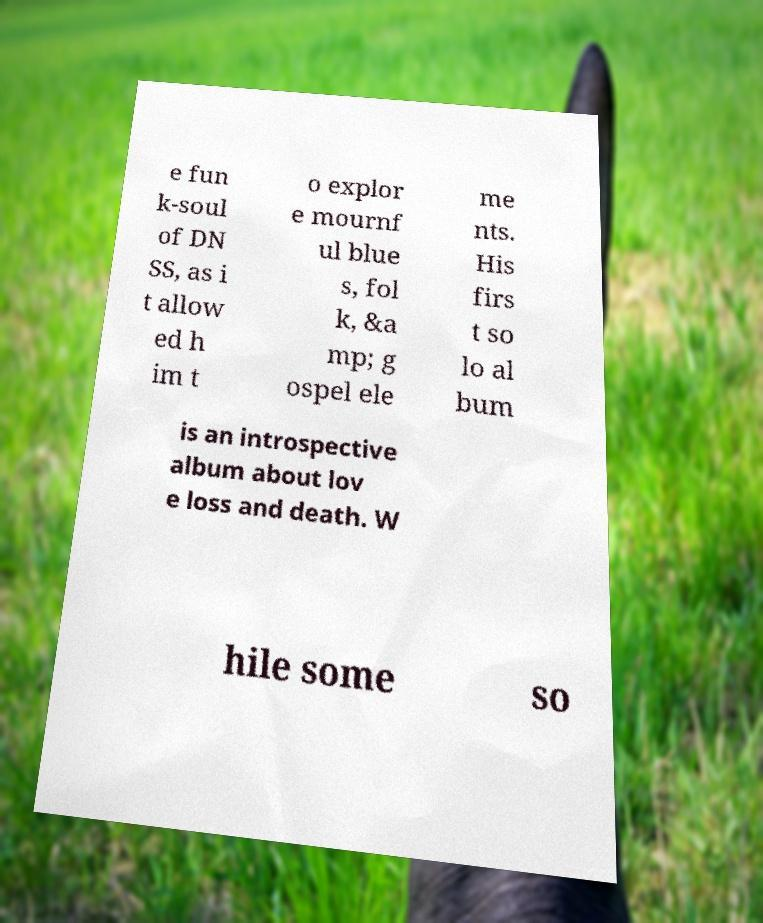For documentation purposes, I need the text within this image transcribed. Could you provide that? e fun k-soul of DN SS, as i t allow ed h im t o explor e mournf ul blue s, fol k, &a mp; g ospel ele me nts. His firs t so lo al bum is an introspective album about lov e loss and death. W hile some so 